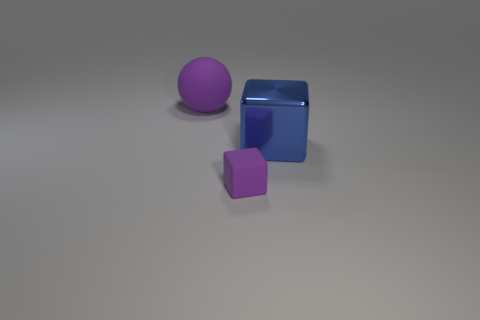Add 2 big matte balls. How many objects exist? 5 Subtract all balls. How many objects are left? 2 Add 2 big purple blocks. How many big purple blocks exist? 2 Subtract 0 green cylinders. How many objects are left? 3 Subtract all tiny purple cubes. Subtract all large cubes. How many objects are left? 1 Add 2 tiny objects. How many tiny objects are left? 3 